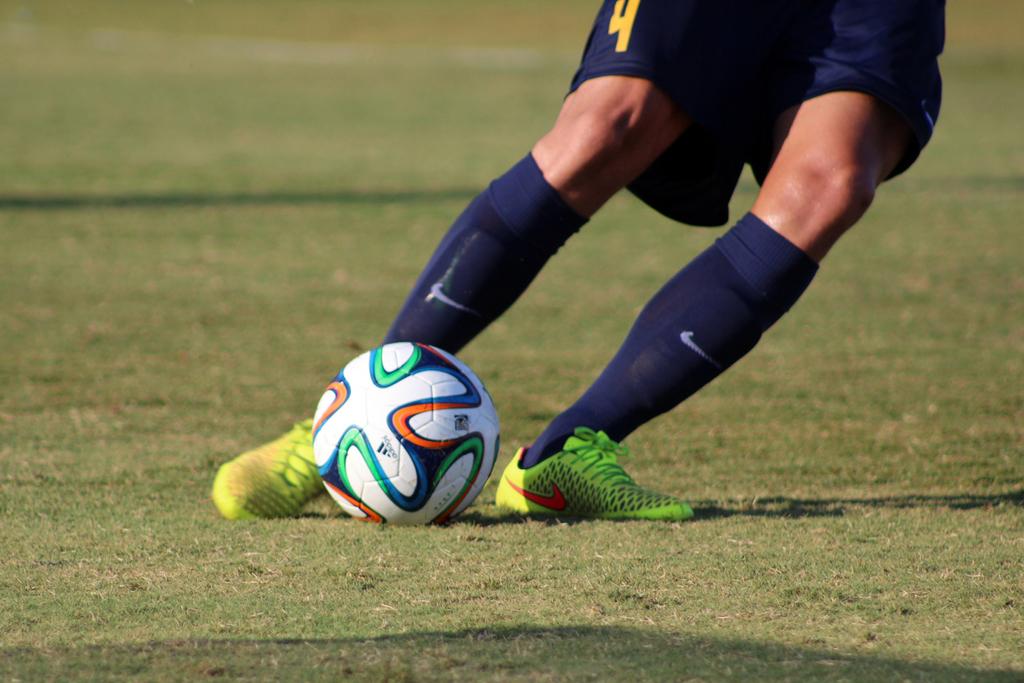What is the number on the shorts?
Provide a succinct answer. 4. 